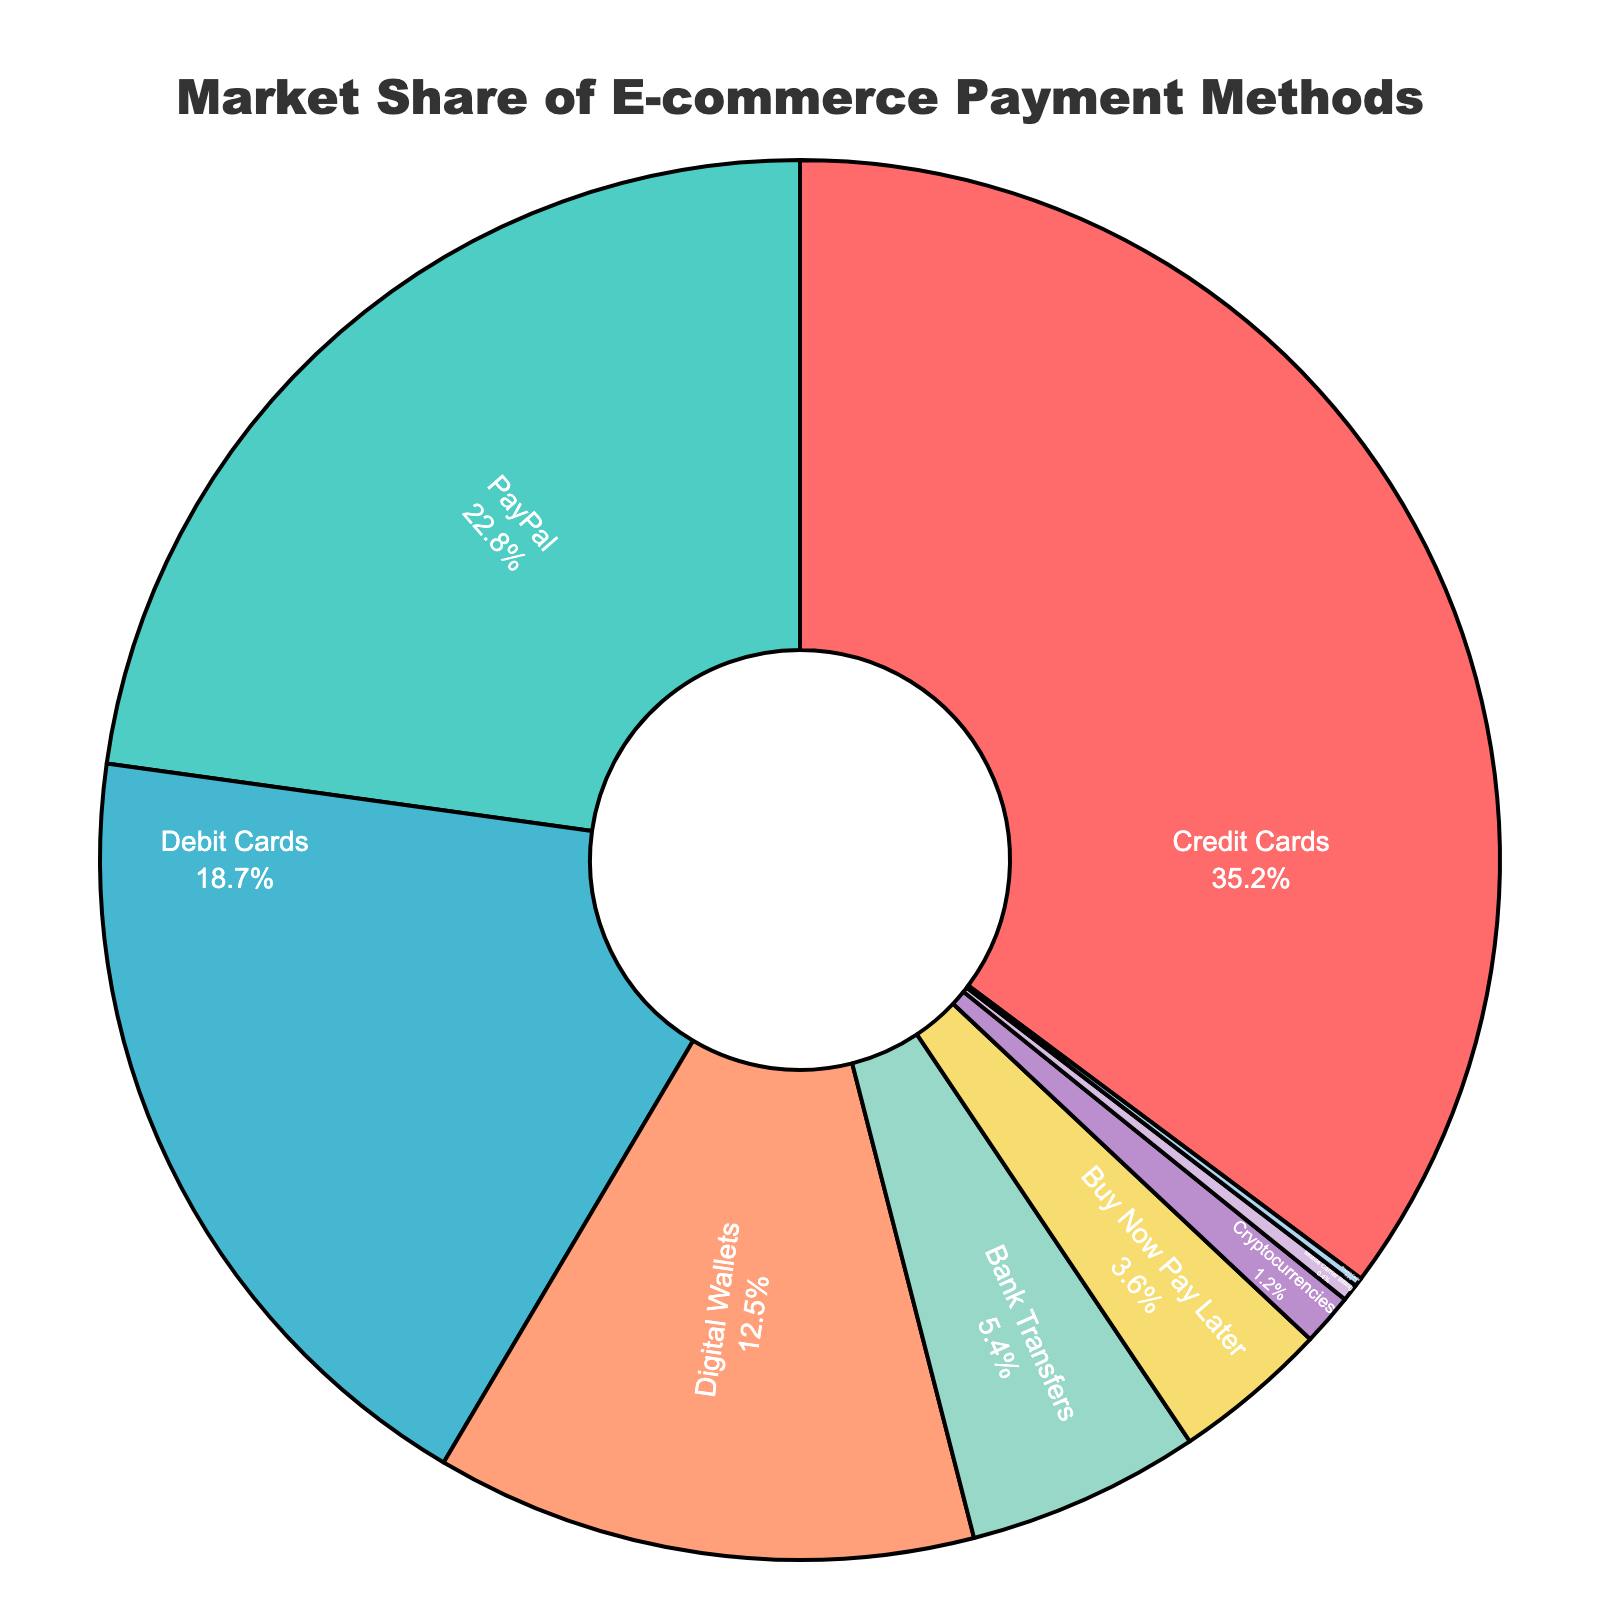Which payment method holds the largest market share? Look at the pie chart and identify the segment with the largest proportion. "Credit Cards" has the largest share.
Answer: Credit Cards What is the combined market share of Credit Cards and PayPal? Add the market share percentages of "Credit Cards" and "PayPal". 35.2 + 22.8 = 58.0
Answer: 58.0% Which payment methods have a market share less than 5%? Identify all the segments of the pie chart with percentages less than 5%. These are "Bank Transfers", "Buy Now Pay Later", "Cryptocurrencies", "Mobile Carrier Billing", and "Prepaid Cards".
Answer: Bank Transfers, Buy Now Pay Later, Cryptocurrencies, Mobile Carrier Billing, Prepaid Cards How much greater is the market share of Digital Wallets compared to Cryptocurrencies? Subtract the market share percentage of "Cryptocurrencies" from that of "Digital Wallets". 12.5 - 1.2 = 11.3
Answer: 11.3% If you combine the market shares of Debit Cards and Digital Wallets, will it exceed that of Credit Cards? Add the market share percentages of "Debit Cards" and "Digital Wallets" and compare with that of "Credit Cards". 18.7 + 12.5 = 31.2; 31.2 < 35.2, so it does not exceed.
Answer: No Is the market share of Cryptocurrencies more than double that of Prepaid Cards? Double the market share percentage of "Prepaid Cards" and compare it with "Cryptocurrencies". 0.2 * 2 = 0.4; Cryptocurrencies at 1.2 is greater than 0.4.
Answer: Yes Which payment methods make up over 50% of the market share together? Identify and sum the market share percentages of the top segments until the sum exceeds 50%. Adding "Credit Cards" (35.2) and "PayPal" (22.8) gives 58.0, which exceeds 50%.
Answer: Credit Cards, PayPal Which segment is represented in green? Identify the segment in green from the pie chart's legend or visual attributes. "PayPal" is represented in green.
Answer: PayPal What is the difference in market share percentage between the most and least popular payment methods? Subtract the smallest market share percentage from the largest. 35.2 (Credit Cards) - 0.2 (Prepaid Cards) = 35.0
Answer: 35.0 How does the market share of Bank Transfers compare to Buy Now Pay Later? Compare the market share percentages directly. "Bank Transfers" has 5.4% and "Buy Now Pay Later" has 3.6%, so Bank Transfers is greater.
Answer: Bank Transfers is greater Calculate the average market share of the top three payment methods. Sum the market shares of the top three methods (Credit Cards, PayPal, Debit Cards) and divide by three. (35.2 + 22.8 + 18.7) / 3 = 25.57
Answer: 25.57 